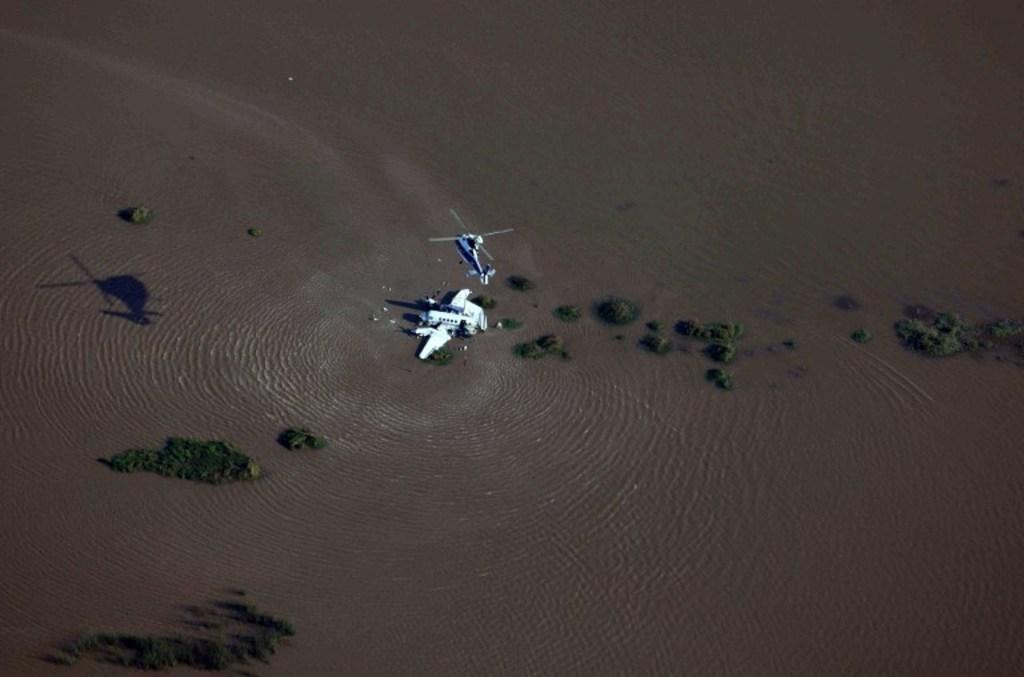What can be seen in the image? Water, trees, plants, and buildings are visible in the image. Can you describe the natural elements in the image? There are trees and plants in the image. What type of man-made structures are present in the image? There are buildings in the image. How many tails can be seen on the buildings in the image? There are no tails visible on the buildings in the image. What type of system is responsible for the water in the image? The facts provided do not give information about a system responsible for the water in the image. Is there a cellar visible in the image? There is no mention of a cellar in the provided facts, so it cannot be determined if one is visible in the image. 